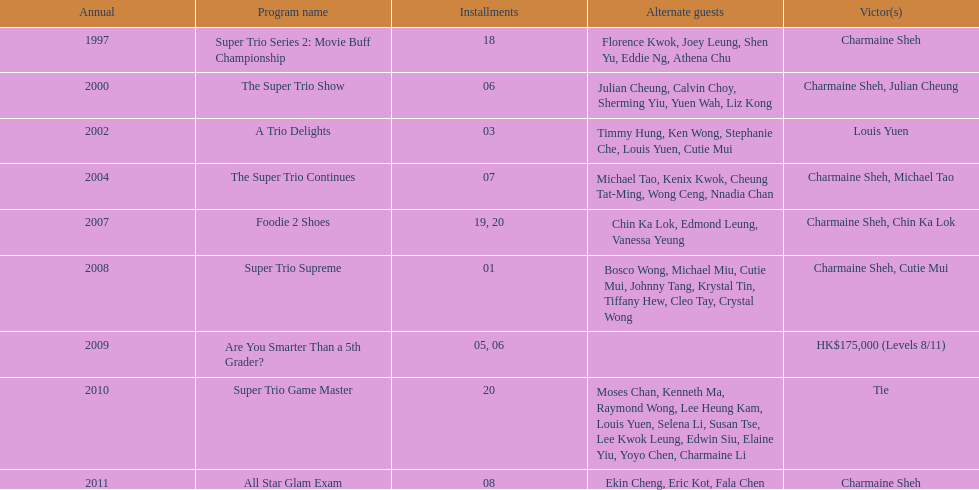How many episodes of the variety show super trio 2: movie buff champions included charmaine sheh? 18. 